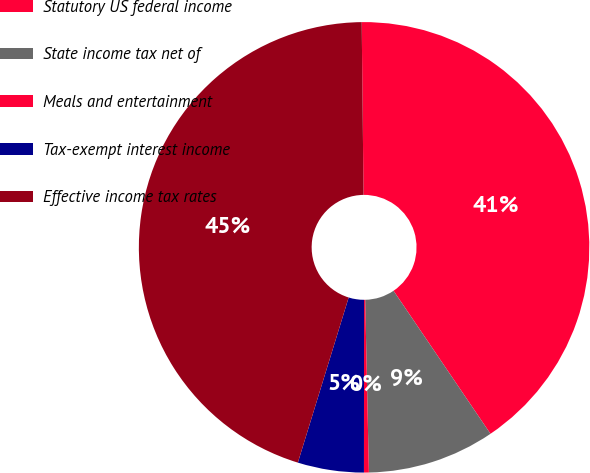<chart> <loc_0><loc_0><loc_500><loc_500><pie_chart><fcel>Statutory US federal income<fcel>State income tax net of<fcel>Meals and entertainment<fcel>Tax-exempt interest income<fcel>Effective income tax rates<nl><fcel>40.69%<fcel>9.14%<fcel>0.35%<fcel>4.74%<fcel>45.08%<nl></chart> 